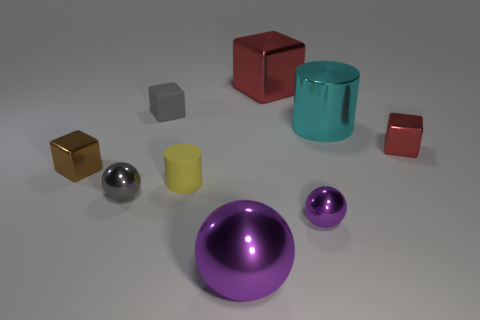Subtract 1 blocks. How many blocks are left? 3 Subtract all cylinders. How many objects are left? 7 Add 4 cylinders. How many cylinders exist? 6 Subtract 0 brown cylinders. How many objects are left? 9 Subtract all matte cubes. Subtract all tiny red objects. How many objects are left? 7 Add 1 spheres. How many spheres are left? 4 